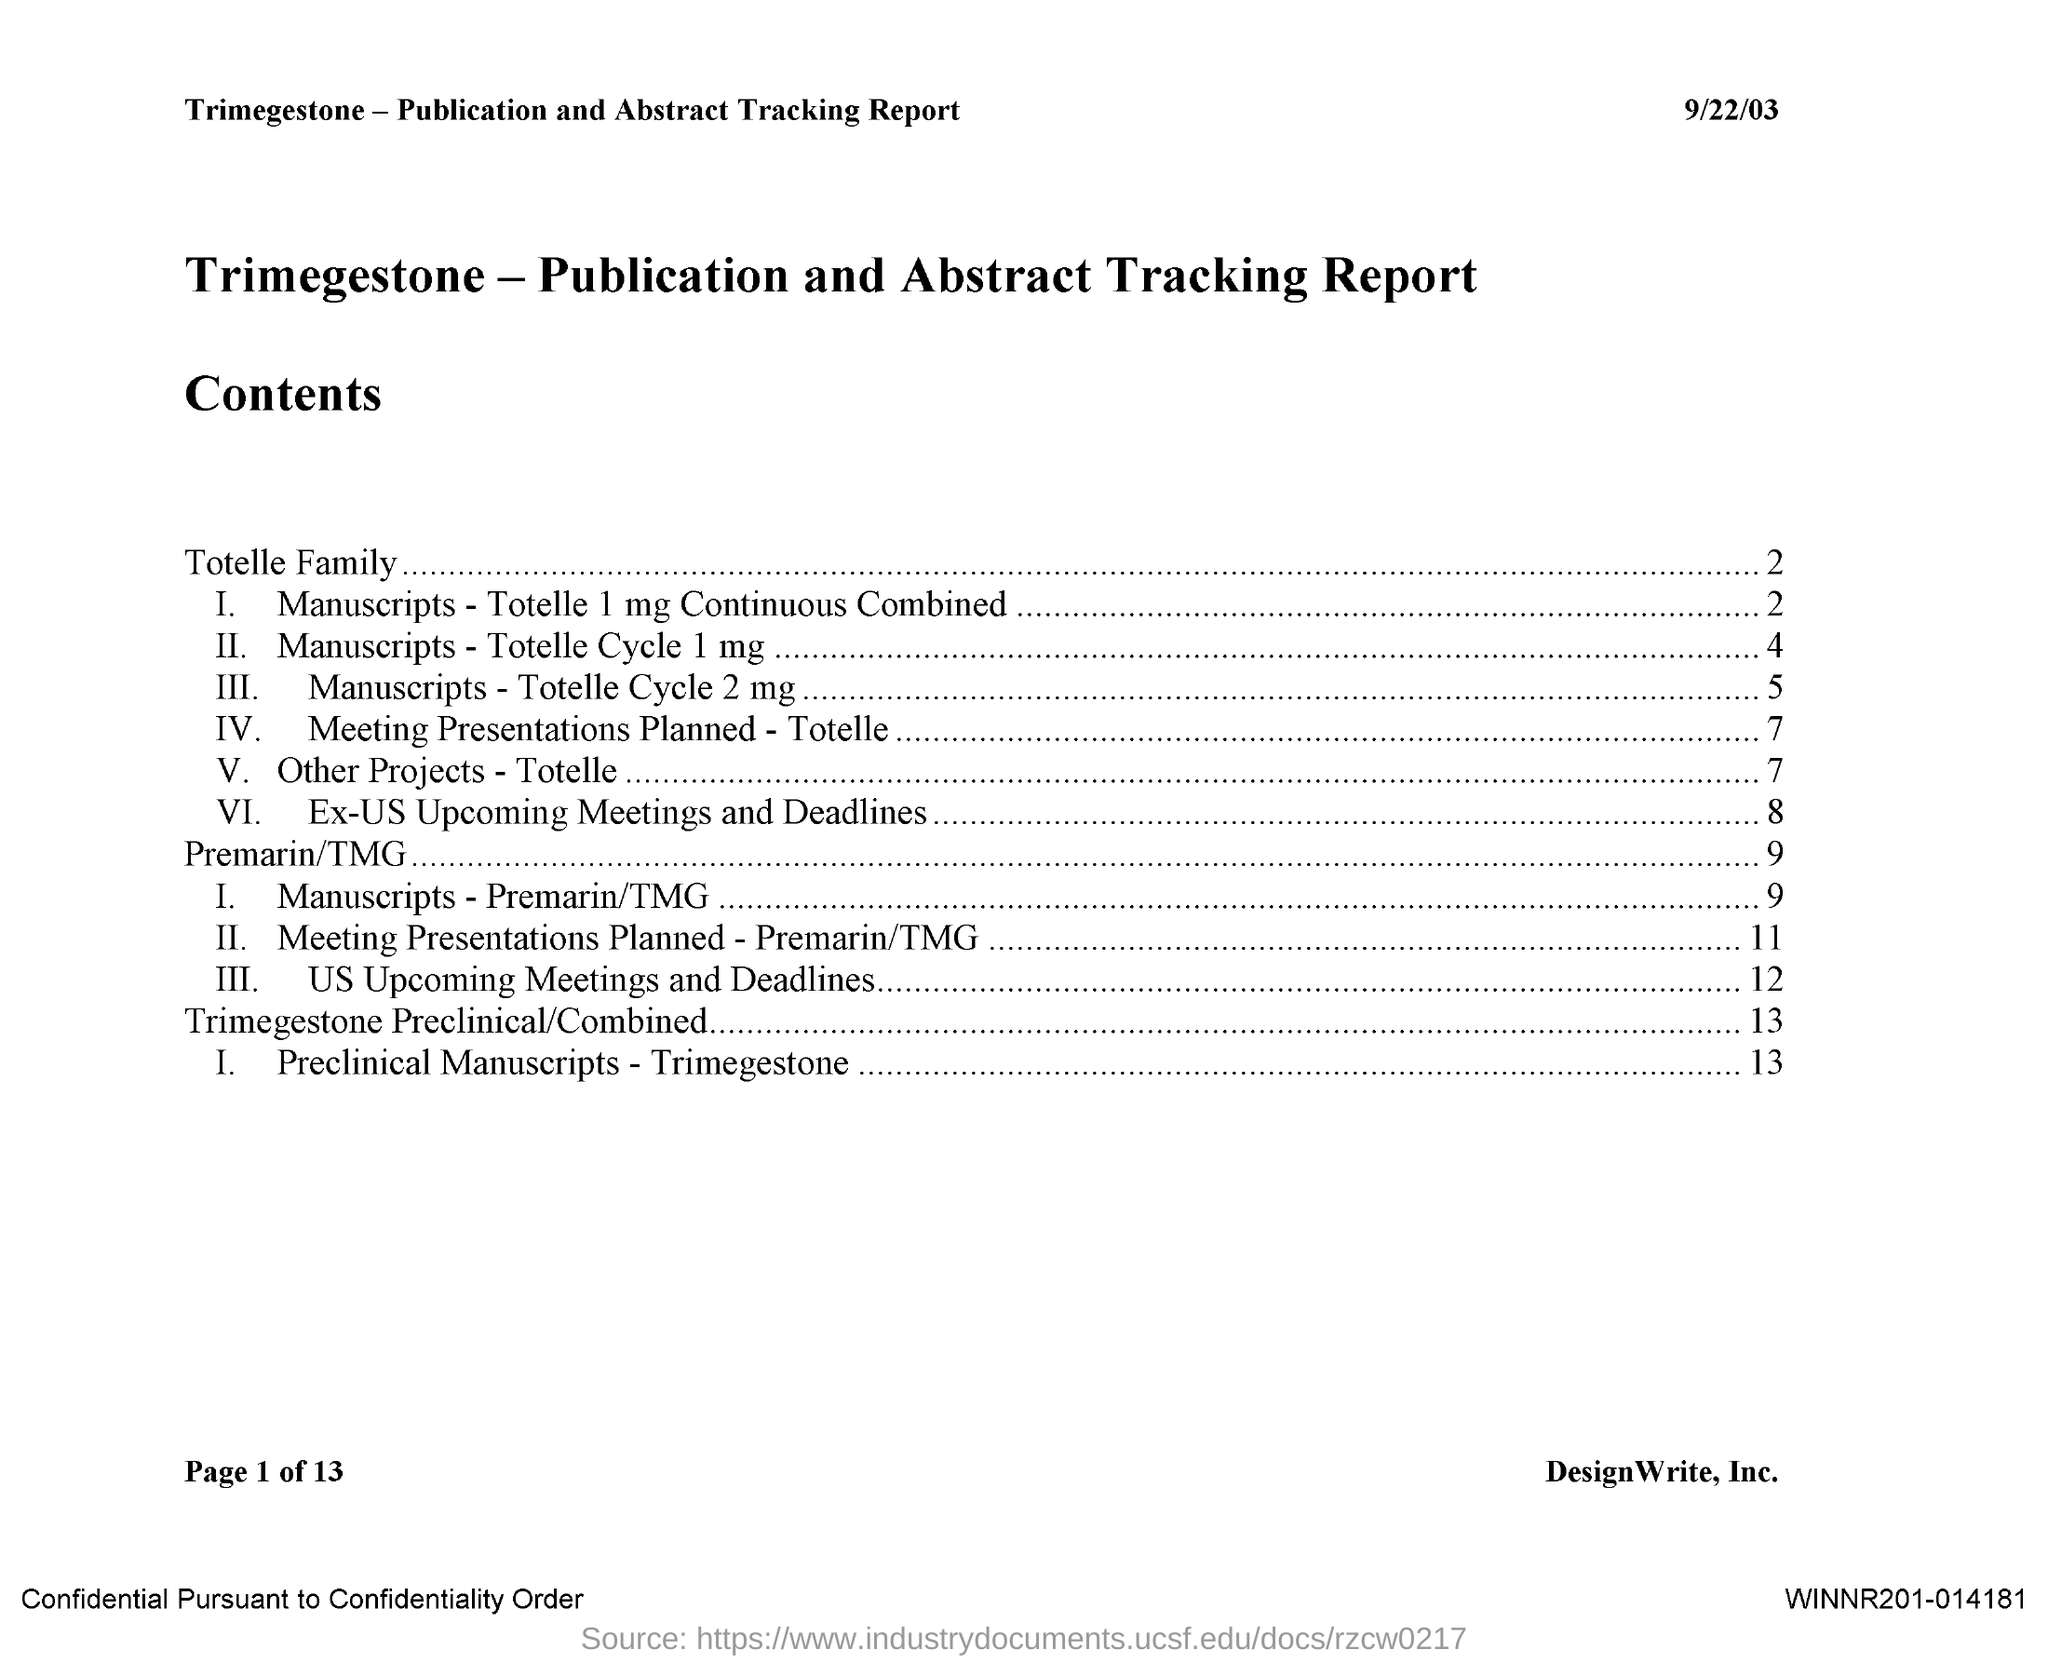List a handful of essential elements in this visual. The third subdivision of the Totell Family is Manuscripts, which includes Totell Cycle 2 milligrams. The second subdivision of Totelle Family is Manuscripts-Totelle Cycle 1mg., which contains a specific amount of material. The fourth subdivision of Totelle Family is Meeting Presentations Planned, which is a subcategory of Totelle. This report is about Trimegestone-Publication and Abstract Tracking Report. Manuscripts is the first subdivision of Totelle Family, which contains 1 mg of Continuous combined contraceptive pills. 